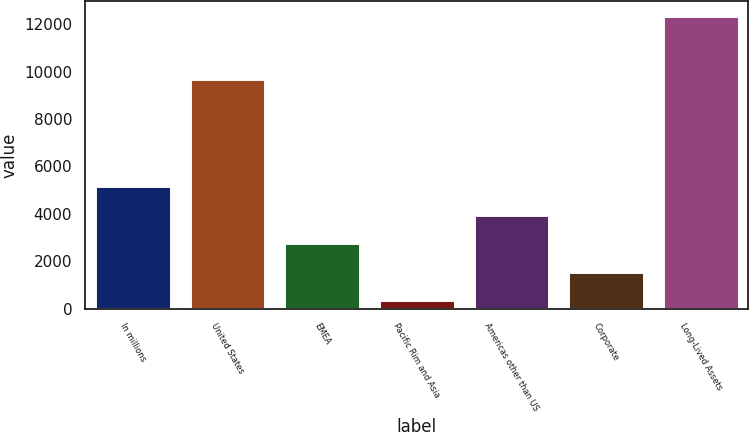Convert chart to OTSL. <chart><loc_0><loc_0><loc_500><loc_500><bar_chart><fcel>In millions<fcel>United States<fcel>EMEA<fcel>Pacific Rim and Asia<fcel>Americas other than US<fcel>Corporate<fcel>Long-Lived Assets<nl><fcel>5150.2<fcel>9683<fcel>2751.6<fcel>353<fcel>3950.9<fcel>1552.3<fcel>12346<nl></chart> 